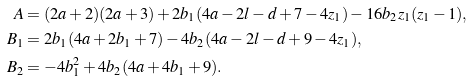Convert formula to latex. <formula><loc_0><loc_0><loc_500><loc_500>A & = ( 2 a + 2 ) ( 2 a + 3 ) + 2 b _ { 1 } ( 4 a - 2 l - d + 7 - 4 z _ { 1 } ) - 1 6 b _ { 2 } z _ { 1 } ( z _ { 1 } - 1 ) , \\ B _ { 1 } & = 2 b _ { 1 } ( 4 a + 2 b _ { 1 } + 7 ) - 4 b _ { 2 } ( 4 a - 2 l - d + 9 - 4 z _ { 1 } ) , \\ B _ { 2 } & = - 4 b _ { 1 } ^ { 2 } + 4 b _ { 2 } ( 4 a + 4 b _ { 1 } + 9 ) .</formula> 